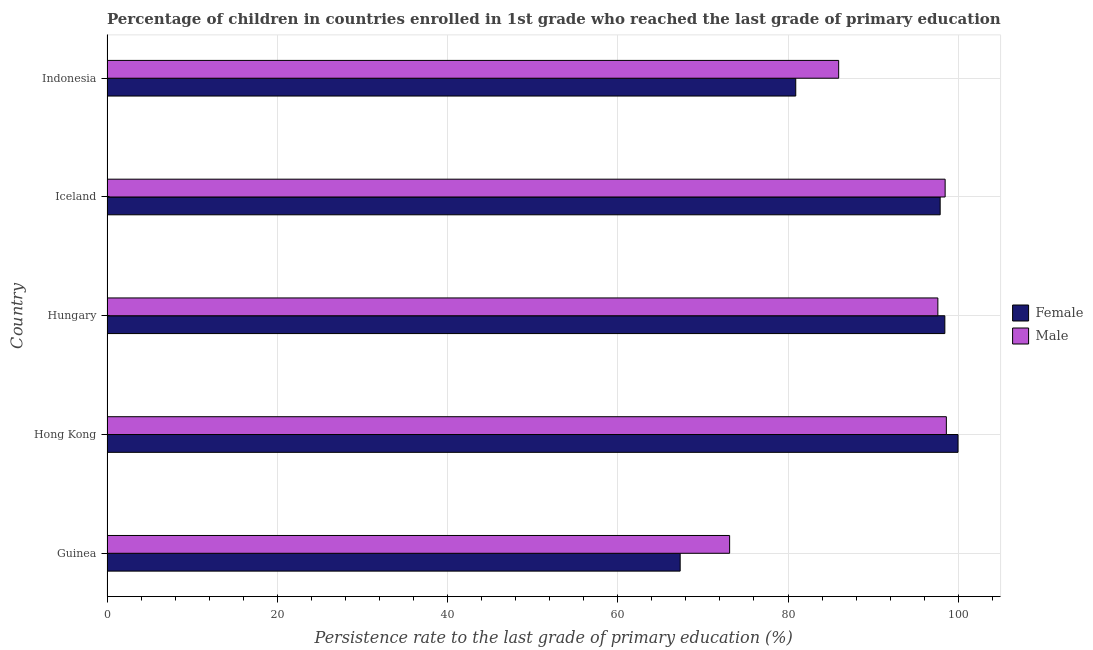How many groups of bars are there?
Provide a short and direct response. 5. Are the number of bars on each tick of the Y-axis equal?
Your answer should be compact. Yes. How many bars are there on the 3rd tick from the top?
Offer a terse response. 2. What is the label of the 5th group of bars from the top?
Offer a terse response. Guinea. In how many cases, is the number of bars for a given country not equal to the number of legend labels?
Provide a succinct answer. 0. What is the persistence rate of female students in Hungary?
Your answer should be compact. 98.42. Across all countries, what is the maximum persistence rate of female students?
Provide a short and direct response. 99.97. Across all countries, what is the minimum persistence rate of male students?
Offer a terse response. 73.14. In which country was the persistence rate of male students maximum?
Provide a short and direct response. Hong Kong. In which country was the persistence rate of female students minimum?
Provide a short and direct response. Guinea. What is the total persistence rate of male students in the graph?
Your answer should be compact. 453.74. What is the difference between the persistence rate of female students in Guinea and that in Iceland?
Offer a very short reply. -30.54. What is the difference between the persistence rate of female students in Hong Kong and the persistence rate of male students in Indonesia?
Your answer should be very brief. 14.02. What is the average persistence rate of male students per country?
Your answer should be compact. 90.75. What is the difference between the persistence rate of male students and persistence rate of female students in Hungary?
Your answer should be very brief. -0.82. What is the ratio of the persistence rate of male students in Guinea to that in Hong Kong?
Your answer should be compact. 0.74. Is the persistence rate of female students in Hong Kong less than that in Iceland?
Offer a terse response. No. Is the difference between the persistence rate of male students in Guinea and Hungary greater than the difference between the persistence rate of female students in Guinea and Hungary?
Offer a very short reply. Yes. What is the difference between the highest and the second highest persistence rate of female students?
Make the answer very short. 1.55. What is the difference between the highest and the lowest persistence rate of male students?
Make the answer very short. 25.46. What does the 1st bar from the top in Guinea represents?
Keep it short and to the point. Male. What does the 1st bar from the bottom in Iceland represents?
Keep it short and to the point. Female. Are all the bars in the graph horizontal?
Your answer should be compact. Yes. What is the difference between two consecutive major ticks on the X-axis?
Provide a succinct answer. 20. How many legend labels are there?
Keep it short and to the point. 2. How are the legend labels stacked?
Keep it short and to the point. Vertical. What is the title of the graph?
Keep it short and to the point. Percentage of children in countries enrolled in 1st grade who reached the last grade of primary education. What is the label or title of the X-axis?
Provide a succinct answer. Persistence rate to the last grade of primary education (%). What is the Persistence rate to the last grade of primary education (%) in Female in Guinea?
Ensure brevity in your answer.  67.33. What is the Persistence rate to the last grade of primary education (%) in Male in Guinea?
Keep it short and to the point. 73.14. What is the Persistence rate to the last grade of primary education (%) in Female in Hong Kong?
Provide a short and direct response. 99.97. What is the Persistence rate to the last grade of primary education (%) of Male in Hong Kong?
Provide a short and direct response. 98.6. What is the Persistence rate to the last grade of primary education (%) of Female in Hungary?
Provide a short and direct response. 98.42. What is the Persistence rate to the last grade of primary education (%) of Male in Hungary?
Make the answer very short. 97.6. What is the Persistence rate to the last grade of primary education (%) of Female in Iceland?
Offer a terse response. 97.87. What is the Persistence rate to the last grade of primary education (%) of Male in Iceland?
Your answer should be compact. 98.46. What is the Persistence rate to the last grade of primary education (%) of Female in Indonesia?
Provide a succinct answer. 80.91. What is the Persistence rate to the last grade of primary education (%) of Male in Indonesia?
Your response must be concise. 85.95. Across all countries, what is the maximum Persistence rate to the last grade of primary education (%) of Female?
Keep it short and to the point. 99.97. Across all countries, what is the maximum Persistence rate to the last grade of primary education (%) of Male?
Offer a terse response. 98.6. Across all countries, what is the minimum Persistence rate to the last grade of primary education (%) of Female?
Your answer should be compact. 67.33. Across all countries, what is the minimum Persistence rate to the last grade of primary education (%) of Male?
Provide a short and direct response. 73.14. What is the total Persistence rate to the last grade of primary education (%) in Female in the graph?
Offer a terse response. 444.5. What is the total Persistence rate to the last grade of primary education (%) of Male in the graph?
Make the answer very short. 453.74. What is the difference between the Persistence rate to the last grade of primary education (%) of Female in Guinea and that in Hong Kong?
Offer a very short reply. -32.64. What is the difference between the Persistence rate to the last grade of primary education (%) of Male in Guinea and that in Hong Kong?
Provide a succinct answer. -25.46. What is the difference between the Persistence rate to the last grade of primary education (%) in Female in Guinea and that in Hungary?
Ensure brevity in your answer.  -31.09. What is the difference between the Persistence rate to the last grade of primary education (%) of Male in Guinea and that in Hungary?
Make the answer very short. -24.46. What is the difference between the Persistence rate to the last grade of primary education (%) in Female in Guinea and that in Iceland?
Provide a succinct answer. -30.54. What is the difference between the Persistence rate to the last grade of primary education (%) of Male in Guinea and that in Iceland?
Keep it short and to the point. -25.32. What is the difference between the Persistence rate to the last grade of primary education (%) of Female in Guinea and that in Indonesia?
Ensure brevity in your answer.  -13.58. What is the difference between the Persistence rate to the last grade of primary education (%) of Male in Guinea and that in Indonesia?
Provide a succinct answer. -12.81. What is the difference between the Persistence rate to the last grade of primary education (%) of Female in Hong Kong and that in Hungary?
Ensure brevity in your answer.  1.55. What is the difference between the Persistence rate to the last grade of primary education (%) in Male in Hong Kong and that in Hungary?
Provide a short and direct response. 1. What is the difference between the Persistence rate to the last grade of primary education (%) of Female in Hong Kong and that in Iceland?
Your answer should be compact. 2.1. What is the difference between the Persistence rate to the last grade of primary education (%) of Male in Hong Kong and that in Iceland?
Your answer should be compact. 0.14. What is the difference between the Persistence rate to the last grade of primary education (%) of Female in Hong Kong and that in Indonesia?
Ensure brevity in your answer.  19.06. What is the difference between the Persistence rate to the last grade of primary education (%) of Male in Hong Kong and that in Indonesia?
Provide a succinct answer. 12.65. What is the difference between the Persistence rate to the last grade of primary education (%) of Female in Hungary and that in Iceland?
Make the answer very short. 0.55. What is the difference between the Persistence rate to the last grade of primary education (%) of Male in Hungary and that in Iceland?
Your response must be concise. -0.86. What is the difference between the Persistence rate to the last grade of primary education (%) of Female in Hungary and that in Indonesia?
Keep it short and to the point. 17.51. What is the difference between the Persistence rate to the last grade of primary education (%) in Male in Hungary and that in Indonesia?
Provide a short and direct response. 11.65. What is the difference between the Persistence rate to the last grade of primary education (%) of Female in Iceland and that in Indonesia?
Your response must be concise. 16.97. What is the difference between the Persistence rate to the last grade of primary education (%) in Male in Iceland and that in Indonesia?
Make the answer very short. 12.51. What is the difference between the Persistence rate to the last grade of primary education (%) in Female in Guinea and the Persistence rate to the last grade of primary education (%) in Male in Hong Kong?
Give a very brief answer. -31.27. What is the difference between the Persistence rate to the last grade of primary education (%) of Female in Guinea and the Persistence rate to the last grade of primary education (%) of Male in Hungary?
Provide a succinct answer. -30.27. What is the difference between the Persistence rate to the last grade of primary education (%) in Female in Guinea and the Persistence rate to the last grade of primary education (%) in Male in Iceland?
Your answer should be very brief. -31.13. What is the difference between the Persistence rate to the last grade of primary education (%) in Female in Guinea and the Persistence rate to the last grade of primary education (%) in Male in Indonesia?
Make the answer very short. -18.62. What is the difference between the Persistence rate to the last grade of primary education (%) in Female in Hong Kong and the Persistence rate to the last grade of primary education (%) in Male in Hungary?
Offer a terse response. 2.37. What is the difference between the Persistence rate to the last grade of primary education (%) of Female in Hong Kong and the Persistence rate to the last grade of primary education (%) of Male in Iceland?
Make the answer very short. 1.51. What is the difference between the Persistence rate to the last grade of primary education (%) of Female in Hong Kong and the Persistence rate to the last grade of primary education (%) of Male in Indonesia?
Provide a short and direct response. 14.02. What is the difference between the Persistence rate to the last grade of primary education (%) of Female in Hungary and the Persistence rate to the last grade of primary education (%) of Male in Iceland?
Offer a terse response. -0.03. What is the difference between the Persistence rate to the last grade of primary education (%) of Female in Hungary and the Persistence rate to the last grade of primary education (%) of Male in Indonesia?
Keep it short and to the point. 12.47. What is the difference between the Persistence rate to the last grade of primary education (%) of Female in Iceland and the Persistence rate to the last grade of primary education (%) of Male in Indonesia?
Your response must be concise. 11.92. What is the average Persistence rate to the last grade of primary education (%) of Female per country?
Provide a short and direct response. 88.9. What is the average Persistence rate to the last grade of primary education (%) of Male per country?
Your response must be concise. 90.75. What is the difference between the Persistence rate to the last grade of primary education (%) in Female and Persistence rate to the last grade of primary education (%) in Male in Guinea?
Ensure brevity in your answer.  -5.81. What is the difference between the Persistence rate to the last grade of primary education (%) of Female and Persistence rate to the last grade of primary education (%) of Male in Hong Kong?
Ensure brevity in your answer.  1.37. What is the difference between the Persistence rate to the last grade of primary education (%) in Female and Persistence rate to the last grade of primary education (%) in Male in Hungary?
Provide a short and direct response. 0.82. What is the difference between the Persistence rate to the last grade of primary education (%) in Female and Persistence rate to the last grade of primary education (%) in Male in Iceland?
Offer a very short reply. -0.58. What is the difference between the Persistence rate to the last grade of primary education (%) in Female and Persistence rate to the last grade of primary education (%) in Male in Indonesia?
Your answer should be very brief. -5.04. What is the ratio of the Persistence rate to the last grade of primary education (%) in Female in Guinea to that in Hong Kong?
Your response must be concise. 0.67. What is the ratio of the Persistence rate to the last grade of primary education (%) of Male in Guinea to that in Hong Kong?
Offer a very short reply. 0.74. What is the ratio of the Persistence rate to the last grade of primary education (%) of Female in Guinea to that in Hungary?
Ensure brevity in your answer.  0.68. What is the ratio of the Persistence rate to the last grade of primary education (%) of Male in Guinea to that in Hungary?
Provide a short and direct response. 0.75. What is the ratio of the Persistence rate to the last grade of primary education (%) of Female in Guinea to that in Iceland?
Your answer should be very brief. 0.69. What is the ratio of the Persistence rate to the last grade of primary education (%) in Male in Guinea to that in Iceland?
Your answer should be very brief. 0.74. What is the ratio of the Persistence rate to the last grade of primary education (%) in Female in Guinea to that in Indonesia?
Your answer should be very brief. 0.83. What is the ratio of the Persistence rate to the last grade of primary education (%) in Male in Guinea to that in Indonesia?
Make the answer very short. 0.85. What is the ratio of the Persistence rate to the last grade of primary education (%) in Female in Hong Kong to that in Hungary?
Ensure brevity in your answer.  1.02. What is the ratio of the Persistence rate to the last grade of primary education (%) in Male in Hong Kong to that in Hungary?
Ensure brevity in your answer.  1.01. What is the ratio of the Persistence rate to the last grade of primary education (%) of Female in Hong Kong to that in Iceland?
Offer a terse response. 1.02. What is the ratio of the Persistence rate to the last grade of primary education (%) of Male in Hong Kong to that in Iceland?
Make the answer very short. 1. What is the ratio of the Persistence rate to the last grade of primary education (%) in Female in Hong Kong to that in Indonesia?
Give a very brief answer. 1.24. What is the ratio of the Persistence rate to the last grade of primary education (%) of Male in Hong Kong to that in Indonesia?
Offer a terse response. 1.15. What is the ratio of the Persistence rate to the last grade of primary education (%) of Female in Hungary to that in Iceland?
Your response must be concise. 1.01. What is the ratio of the Persistence rate to the last grade of primary education (%) of Male in Hungary to that in Iceland?
Offer a terse response. 0.99. What is the ratio of the Persistence rate to the last grade of primary education (%) in Female in Hungary to that in Indonesia?
Offer a very short reply. 1.22. What is the ratio of the Persistence rate to the last grade of primary education (%) of Male in Hungary to that in Indonesia?
Provide a short and direct response. 1.14. What is the ratio of the Persistence rate to the last grade of primary education (%) in Female in Iceland to that in Indonesia?
Provide a short and direct response. 1.21. What is the ratio of the Persistence rate to the last grade of primary education (%) in Male in Iceland to that in Indonesia?
Ensure brevity in your answer.  1.15. What is the difference between the highest and the second highest Persistence rate to the last grade of primary education (%) in Female?
Provide a short and direct response. 1.55. What is the difference between the highest and the second highest Persistence rate to the last grade of primary education (%) in Male?
Provide a short and direct response. 0.14. What is the difference between the highest and the lowest Persistence rate to the last grade of primary education (%) in Female?
Provide a succinct answer. 32.64. What is the difference between the highest and the lowest Persistence rate to the last grade of primary education (%) in Male?
Your answer should be compact. 25.46. 